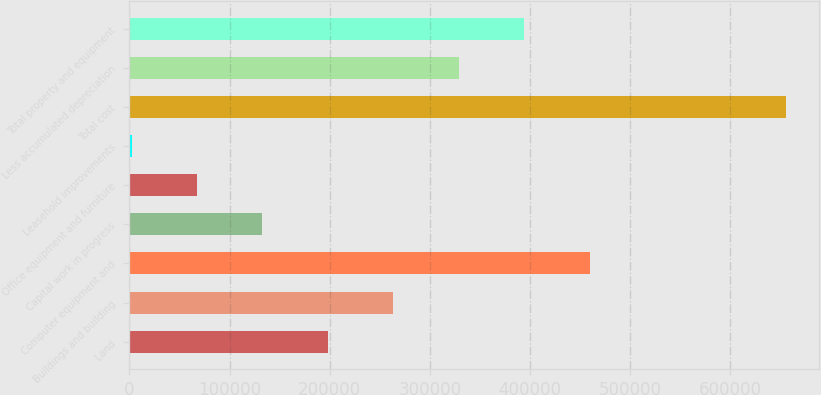Convert chart to OTSL. <chart><loc_0><loc_0><loc_500><loc_500><bar_chart><fcel>Land<fcel>Buildings and building<fcel>Computer equipment and<fcel>Capital work in progress<fcel>Office equipment and furniture<fcel>Leasehold improvements<fcel>Total cost<fcel>Less accumulated depreciation<fcel>Total property and equipment<nl><fcel>198258<fcel>263614<fcel>459682<fcel>132901<fcel>67545.2<fcel>2189<fcel>655751<fcel>328970<fcel>394326<nl></chart> 